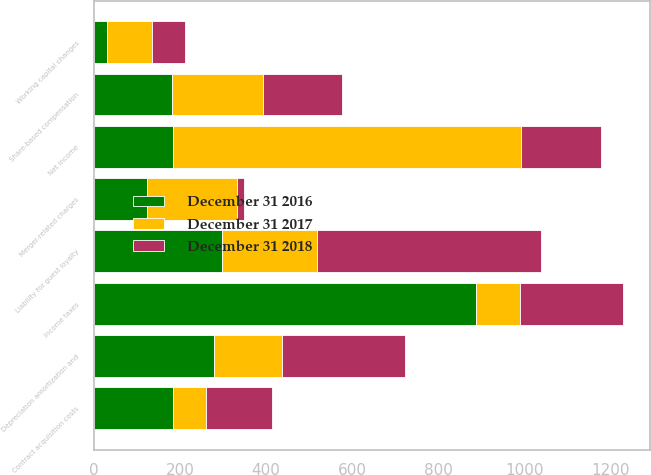Convert chart to OTSL. <chart><loc_0><loc_0><loc_500><loc_500><stacked_bar_chart><ecel><fcel>Net income<fcel>Depreciation amortization and<fcel>Share-based compensation<fcel>Income taxes<fcel>Liability for guest loyalty<fcel>Contract acquisition costs<fcel>Merger-related charges<fcel>Working capital changes<nl><fcel>December 31 2018<fcel>184.5<fcel>284<fcel>184<fcel>239<fcel>520<fcel>152<fcel>16<fcel>76<nl><fcel>December 31 2016<fcel>184.5<fcel>279<fcel>181<fcel>887<fcel>298<fcel>185<fcel>124<fcel>30<nl><fcel>December 31 2017<fcel>808<fcel>159<fcel>212<fcel>103<fcel>221<fcel>76<fcel>209<fcel>106<nl></chart> 